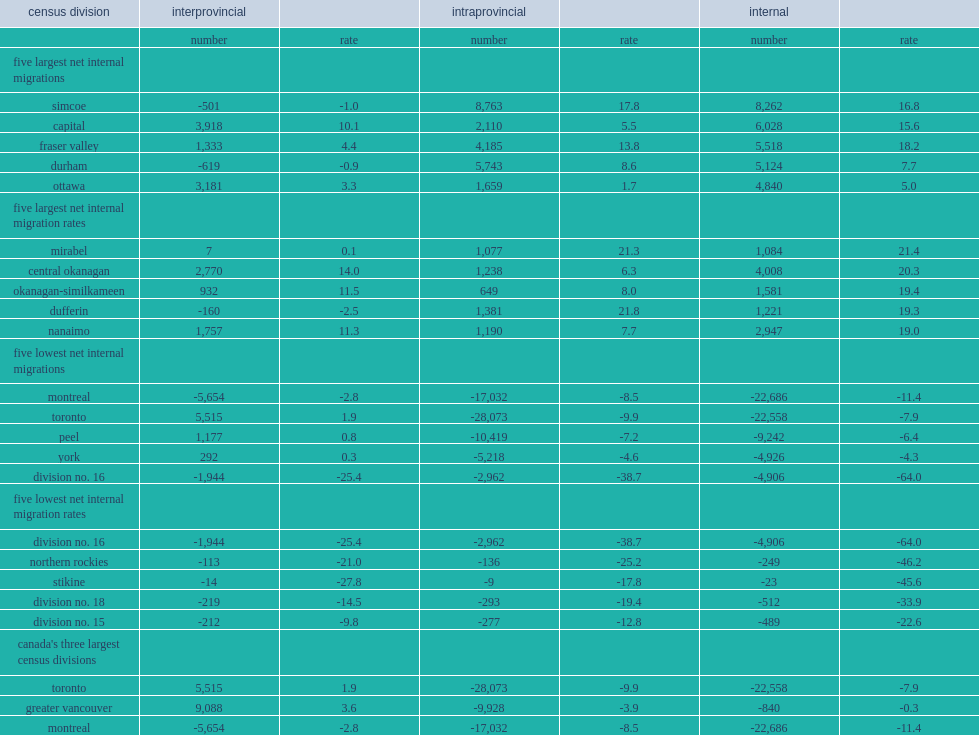What had the largest internal migration rate in canada for 2015/2016? Mirabel. What was the intraprovincial migration rate per thousand of the mirabel cd (quebec)? 21.3. Which place had the second highest intraprovincial migration rate in canada? Mirabel. Which place had the second largest internal migration rate over 2015/2016? Central okanagan. Which place had the third largest internal migration rate over 2015/2016? Okanagan-similkameen. Which place had the fourth largest internal migration rate? Dufferin. What was the ontario cd of dufferin's internal migration rate per thousand? 19.3. Which cd had the largest intraprovincial migration rate in the country? Dufferin. Which cd had the fifth largest internal migration rate in 2015/2016? Nanaimo. Which cd had the lowest internal migration rate in the country in 2015/2016? Division no. 16. Which cd had the lowest intraprovincial migration rate in canada? Division no. 16. Which cd had the second smallest interprovincial migration rate in canada? Division no. 16. Which cd had the second smallest internal migration rate? Northern rockies. Which cd had the third smallest internal migration rate? Stikine. Which cd had the fourth lowest internal migration rate in the country? Division no. 18. Which cd had the fifth smallest internal migration rate in the country? Division no. 15. 